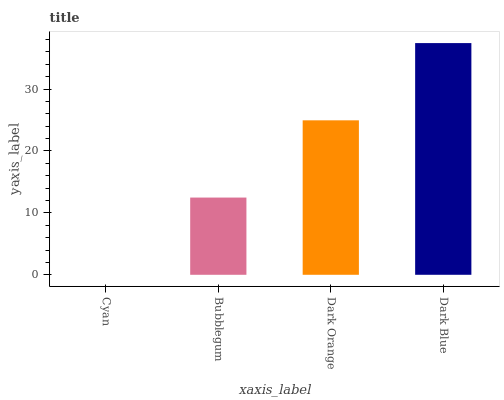Is Cyan the minimum?
Answer yes or no. Yes. Is Dark Blue the maximum?
Answer yes or no. Yes. Is Bubblegum the minimum?
Answer yes or no. No. Is Bubblegum the maximum?
Answer yes or no. No. Is Bubblegum greater than Cyan?
Answer yes or no. Yes. Is Cyan less than Bubblegum?
Answer yes or no. Yes. Is Cyan greater than Bubblegum?
Answer yes or no. No. Is Bubblegum less than Cyan?
Answer yes or no. No. Is Dark Orange the high median?
Answer yes or no. Yes. Is Bubblegum the low median?
Answer yes or no. Yes. Is Bubblegum the high median?
Answer yes or no. No. Is Dark Blue the low median?
Answer yes or no. No. 